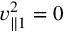Convert formula to latex. <formula><loc_0><loc_0><loc_500><loc_500>v _ { \| 1 } ^ { 2 } = 0</formula> 